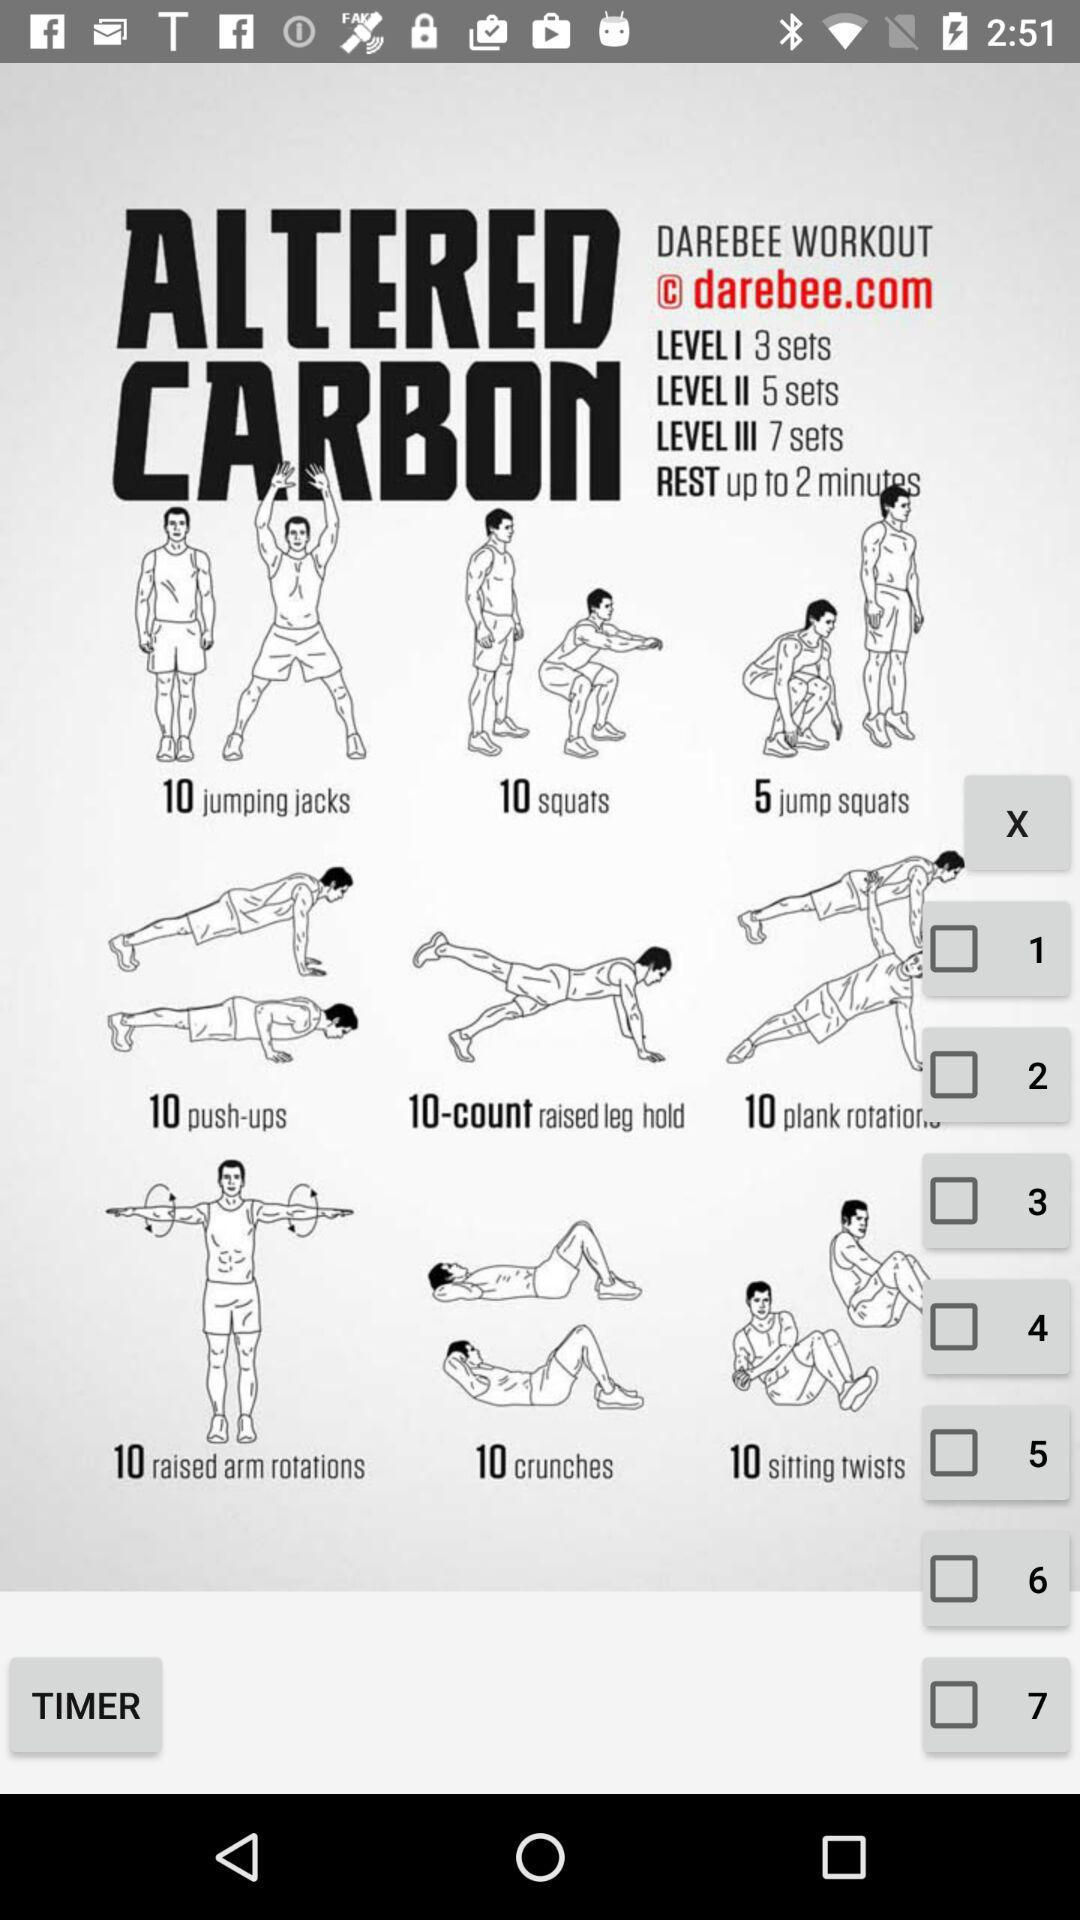What is the application name?
When the provided information is insufficient, respond with <no answer>. <no answer> 